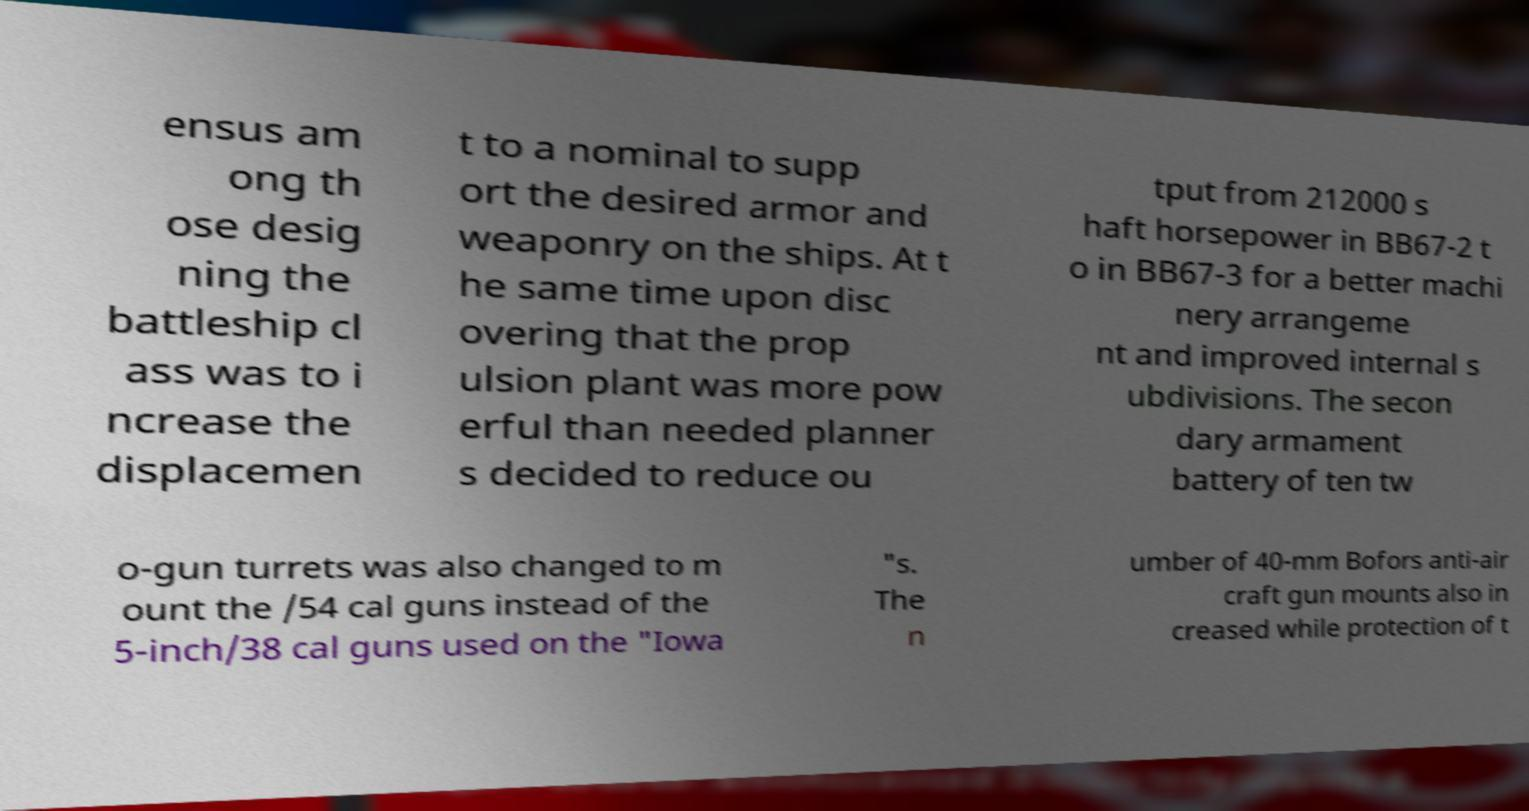I need the written content from this picture converted into text. Can you do that? ensus am ong th ose desig ning the battleship cl ass was to i ncrease the displacemen t to a nominal to supp ort the desired armor and weaponry on the ships. At t he same time upon disc overing that the prop ulsion plant was more pow erful than needed planner s decided to reduce ou tput from 212000 s haft horsepower in BB67-2 t o in BB67-3 for a better machi nery arrangeme nt and improved internal s ubdivisions. The secon dary armament battery of ten tw o-gun turrets was also changed to m ount the /54 cal guns instead of the 5-inch/38 cal guns used on the "Iowa "s. The n umber of 40-mm Bofors anti-air craft gun mounts also in creased while protection of t 